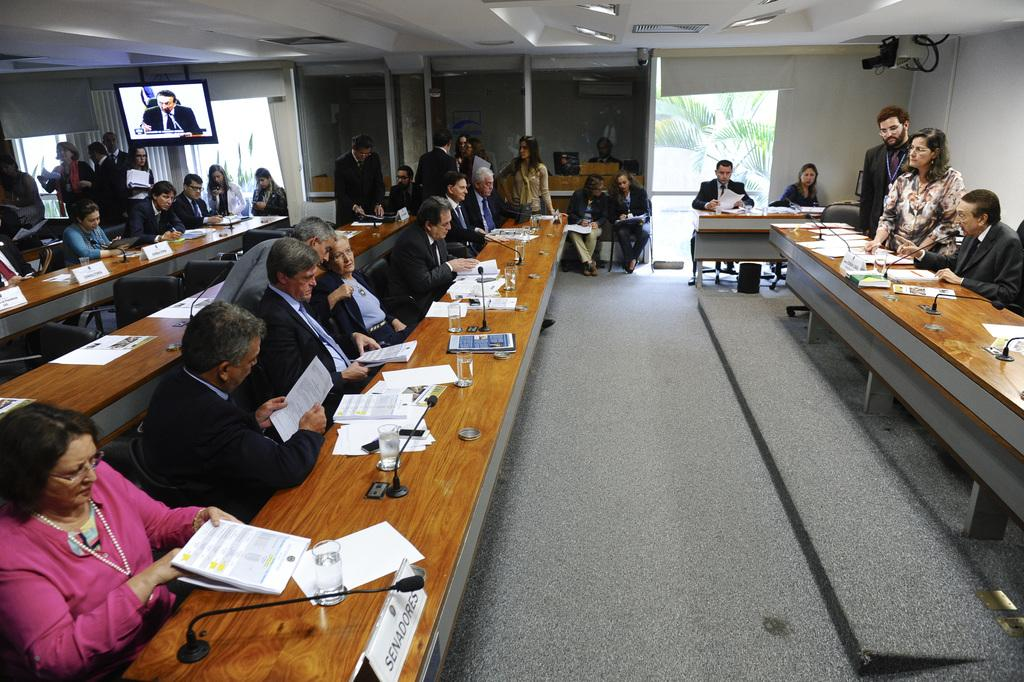What are the people in the image doing? There is a group of people sitting in chairs. What is in front of the group of people? There is a table in front of the group of people. What items can be found on the table? The table consists of books, papers, a microphone (mike), and a glass. Is there any electronic device visible in the image? Yes, there is a television in the top left corner of the image. What type of smell can be detected coming from the yard in the image? There is no yard or smell present in the image; it features a group of people sitting around a table with various items. 